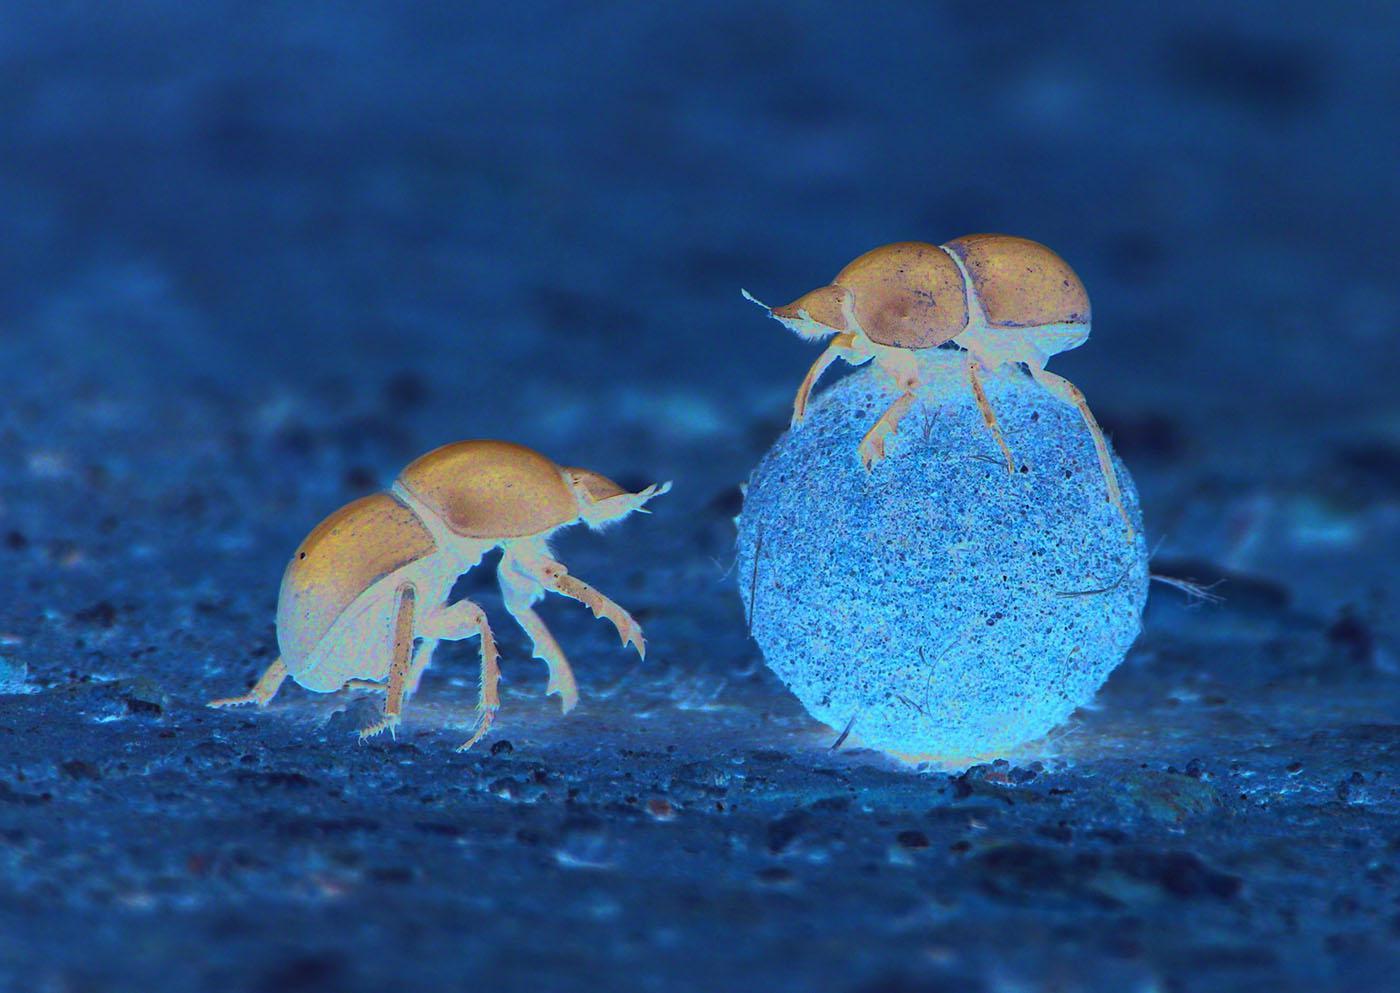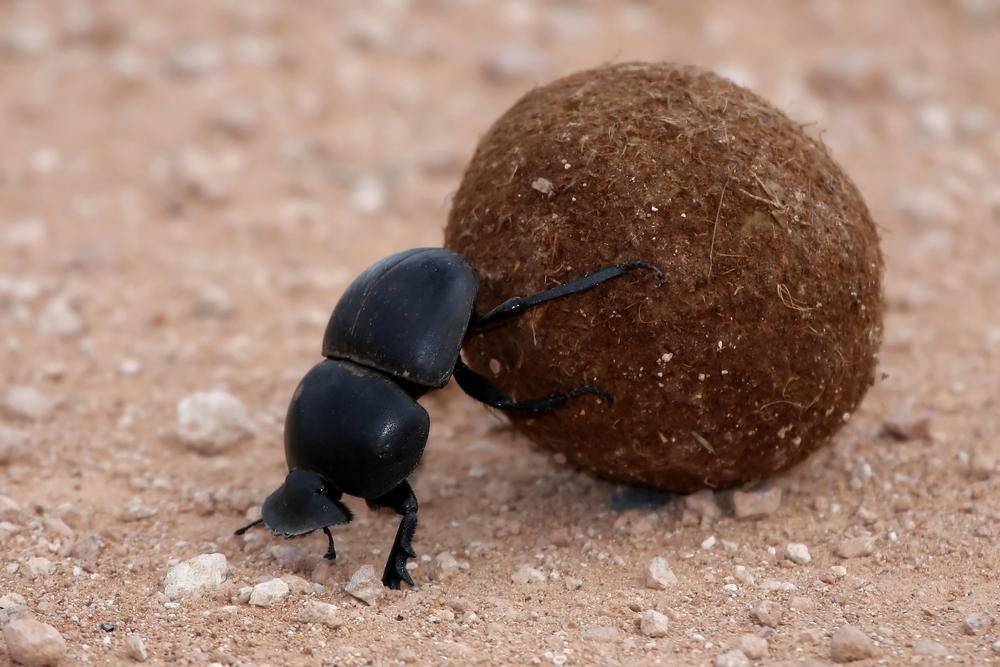The first image is the image on the left, the second image is the image on the right. Assess this claim about the two images: "At least one beatle has its hind legs on a ball while its front legs are on the ground.". Correct or not? Answer yes or no. Yes. 